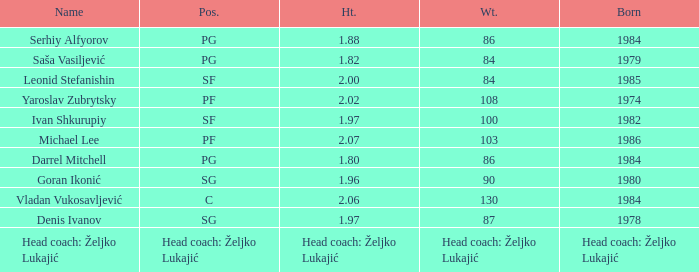What is the weight of the person born in 1980? 90.0. Give me the full table as a dictionary. {'header': ['Name', 'Pos.', 'Ht.', 'Wt.', 'Born'], 'rows': [['Serhiy Alfyorov', 'PG', '1.88', '86', '1984'], ['Saša Vasiljević', 'PG', '1.82', '84', '1979'], ['Leonid Stefanishin', 'SF', '2.00', '84', '1985'], ['Yaroslav Zubrytsky', 'PF', '2.02', '108', '1974'], ['Ivan Shkurupiy', 'SF', '1.97', '100', '1982'], ['Michael Lee', 'PF', '2.07', '103', '1986'], ['Darrel Mitchell', 'PG', '1.80', '86', '1984'], ['Goran Ikonić', 'SG', '1.96', '90', '1980'], ['Vladan Vukosavljević', 'C', '2.06', '130', '1984'], ['Denis Ivanov', 'SG', '1.97', '87', '1978'], ['Head coach: Željko Lukajić', 'Head coach: Željko Lukajić', 'Head coach: Željko Lukajić', 'Head coach: Željko Lukajić', 'Head coach: Željko Lukajić']]} 